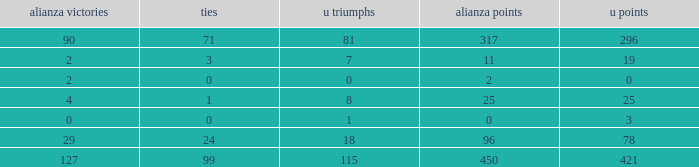What is the sum of Alianza Wins, when Alianza Goals is "317, and when U Goals is greater than 296? None. 